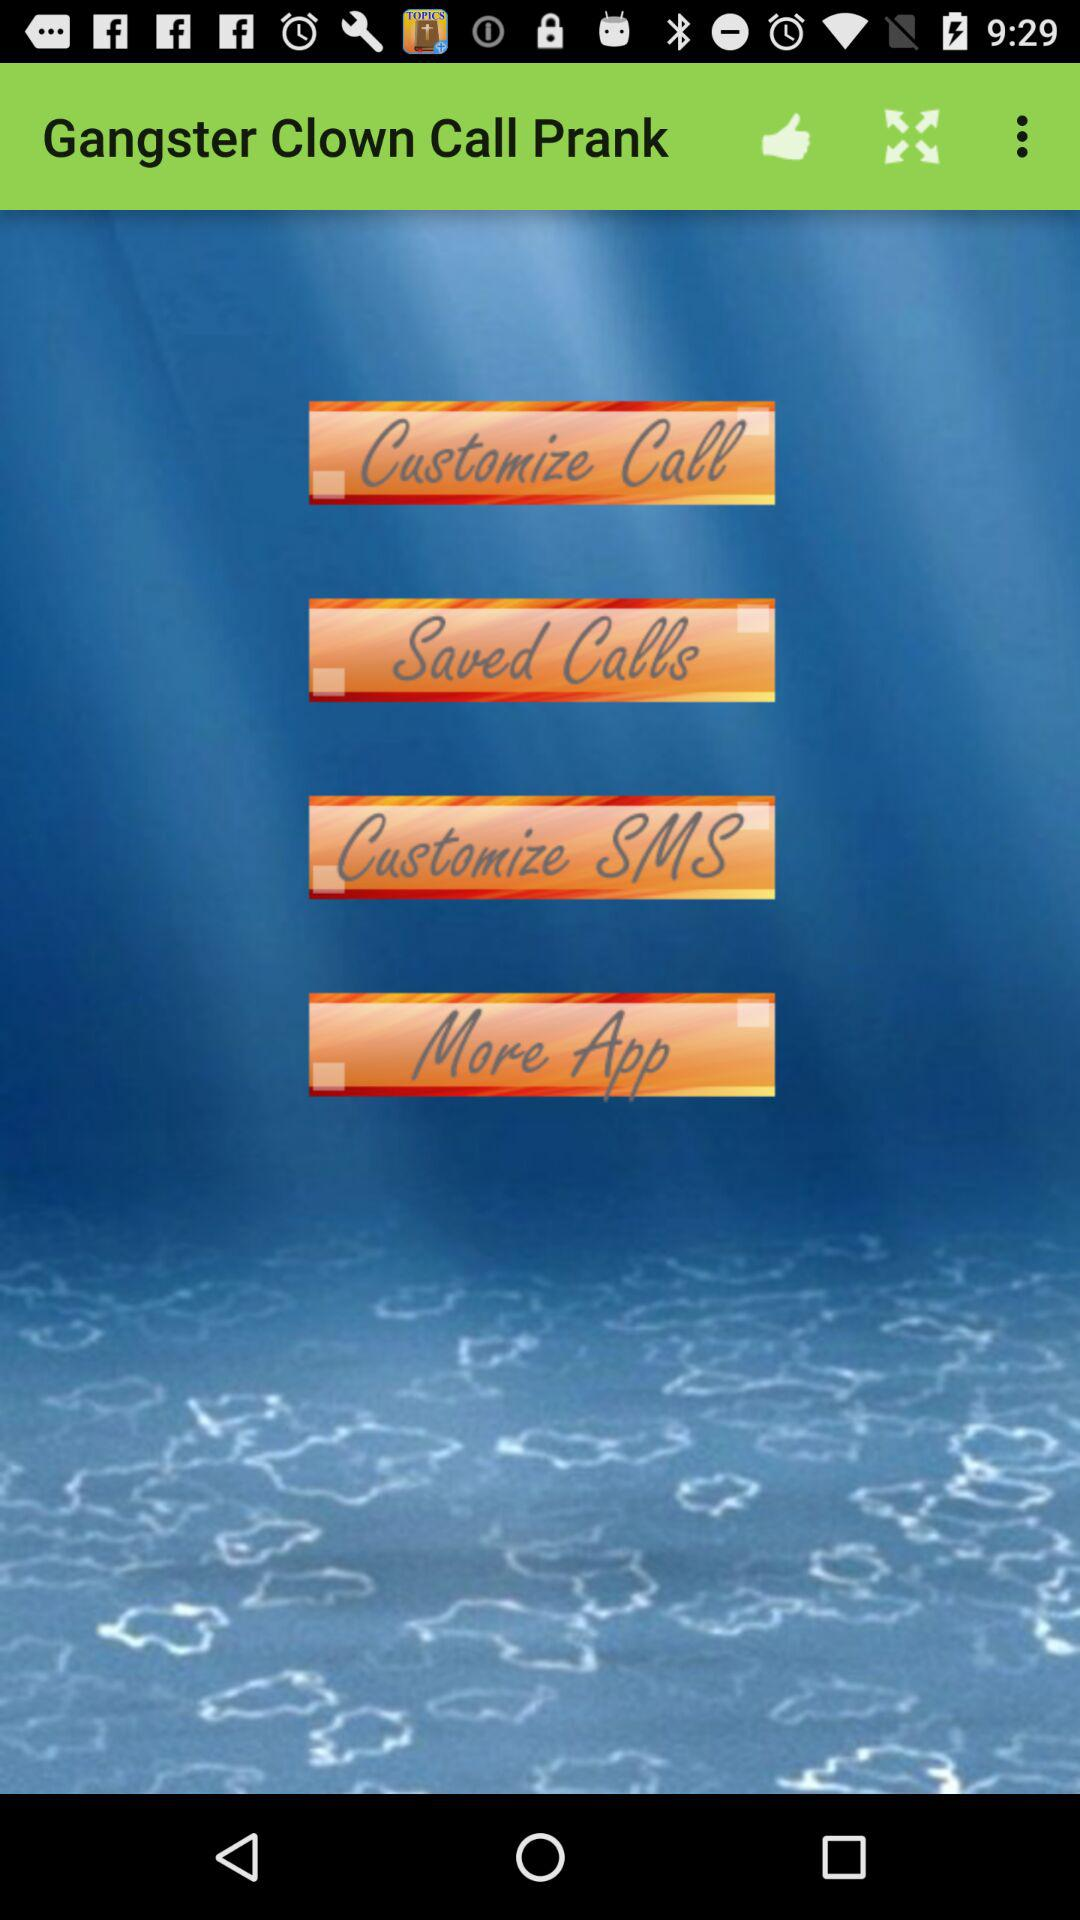How many saved calls are there?
When the provided information is insufficient, respond with <no answer>. <no answer> 